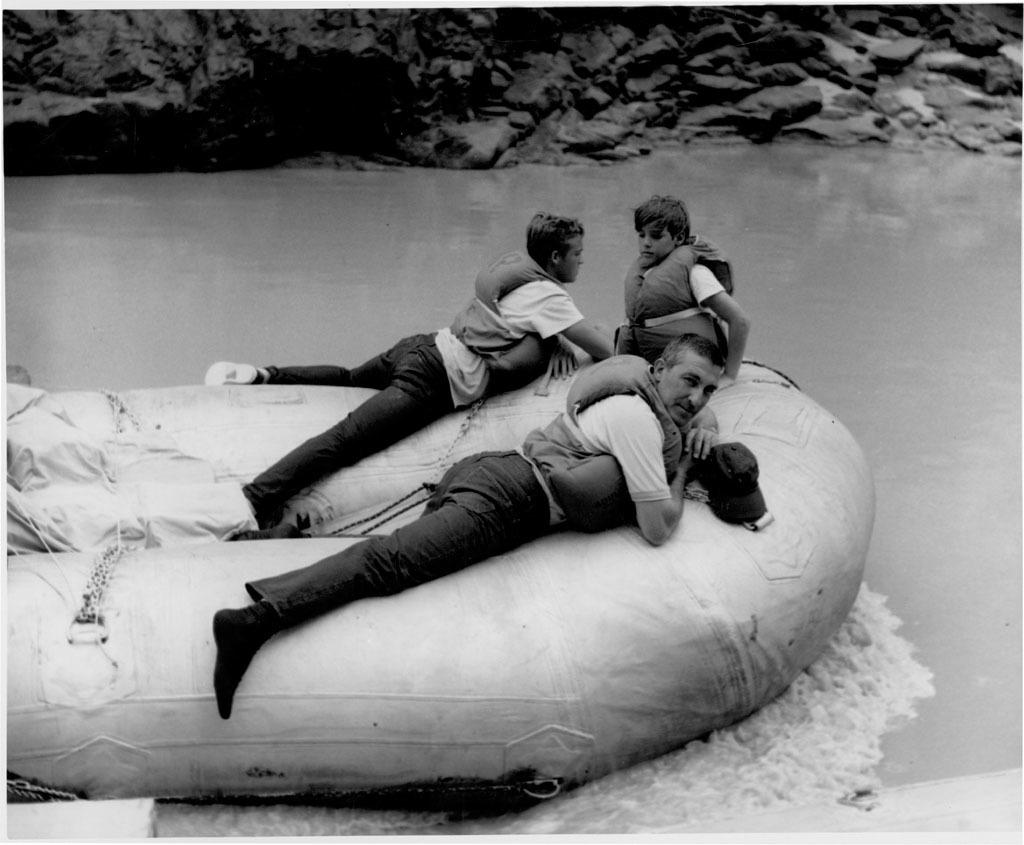What is the color scheme of the image? The image is black and white. What is the person in the image doing? There is a person sitting in the image. What are the two persons in the image doing? The two persons are lying on an inflatable boat in the image. Where is the inflatable boat located? The inflatable boat is on the water. What can be seen in the background of the image? There are rocks visible in the background of the image. What type of throat condition does the person sitting in the image have? There is no indication of any throat condition in the image, as it only shows a person sitting. What kind of beast can be seen in the image? There are no beasts present in the image; it features a person sitting and two persons lying on an inflatable boat on the water. 